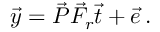<formula> <loc_0><loc_0><loc_500><loc_500>\vec { y } = \vec { P } \vec { F } _ { r } \vec { t } + \vec { e } \, .</formula> 